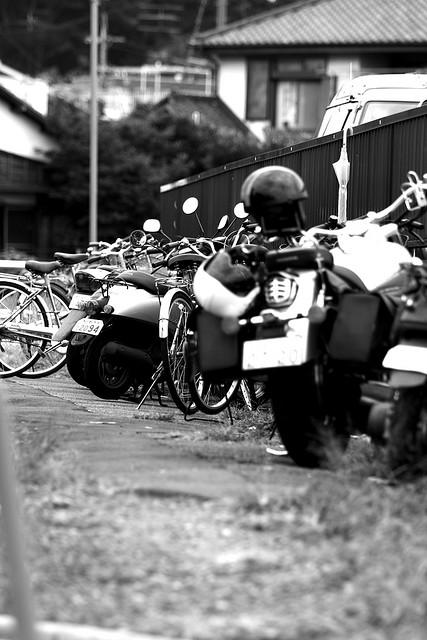What kind of transportation is shown? Please explain your reasoning. road. The vehicles are bicycles and motorcycles. these cannot travel on tracks, cannot fly, and cannot float on water. 